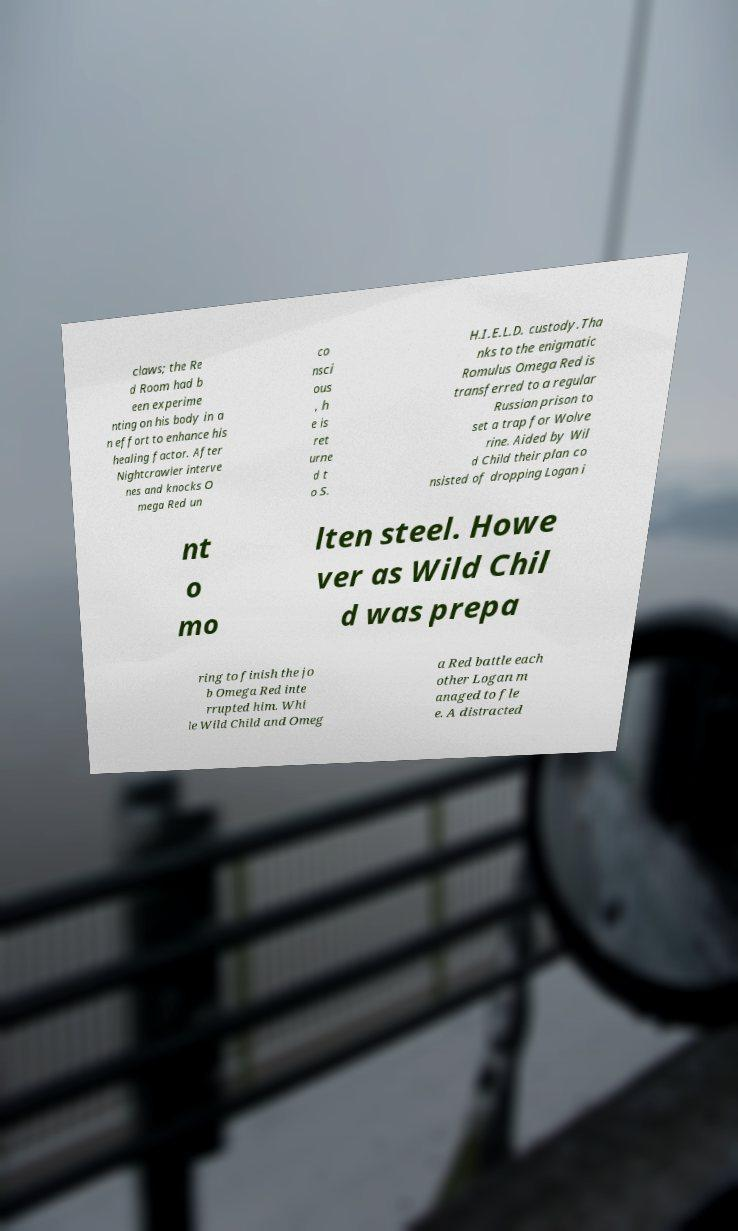There's text embedded in this image that I need extracted. Can you transcribe it verbatim? claws; the Re d Room had b een experime nting on his body in a n effort to enhance his healing factor. After Nightcrawler interve nes and knocks O mega Red un co nsci ous , h e is ret urne d t o S. H.I.E.L.D. custody.Tha nks to the enigmatic Romulus Omega Red is transferred to a regular Russian prison to set a trap for Wolve rine. Aided by Wil d Child their plan co nsisted of dropping Logan i nt o mo lten steel. Howe ver as Wild Chil d was prepa ring to finish the jo b Omega Red inte rrupted him. Whi le Wild Child and Omeg a Red battle each other Logan m anaged to fle e. A distracted 